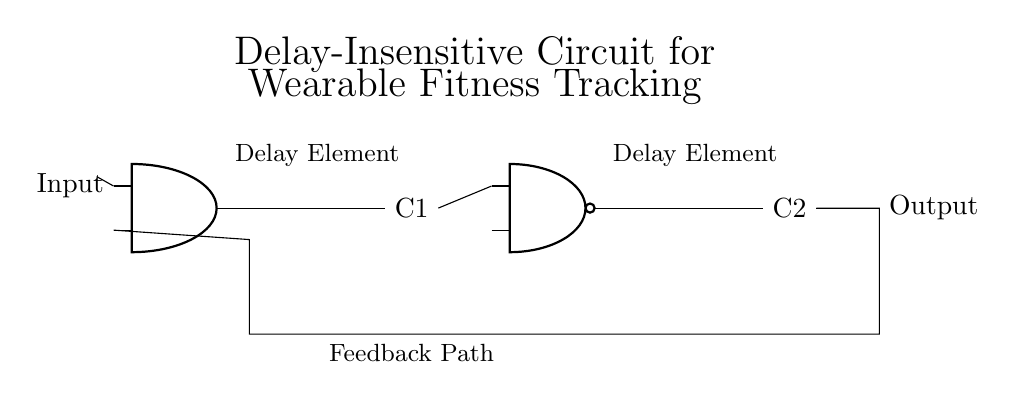What components are used in this circuit? The circuit includes two capacitors and two logic gates (an AND gate and a NAND gate). The components are identified visually by their respective symbols.
Answer: Capacitor, AND gate, NAND gate What is the function of the AND gate? The AND gate outputs a high signal only if both its inputs are high. This is determined by examining its symbol and the connections.
Answer: Logic AND How many delay elements are present in this circuit? There are two delay elements shown, one connected to the output of the AND gate and the other connected to the NAND gate. This is inferred from the labels above the components in the diagram.
Answer: Two What type of feedback is shown in the circuit? The feedback path connects the output of the second capacitor back to an input of the AND gate, creating a loop that affects the circuit's behavior over time. This is evident from the directed connection in the diagram.
Answer: Feedback loop What is the output of the circuit based on the initial input? The output will depend on the input given to the AND gate initially. The NAND gate setup allows the input conditions to determine the final output, reflecting asynchronous behavior.
Answer: Varies What type of circuit is represented here? This circuit is a delay-insensitive circuit, which is designed to operate regardless of the timing of signals. It is evident from its structure and purpose indicated in the title of the diagram.
Answer: Delay-insensitive circuit 